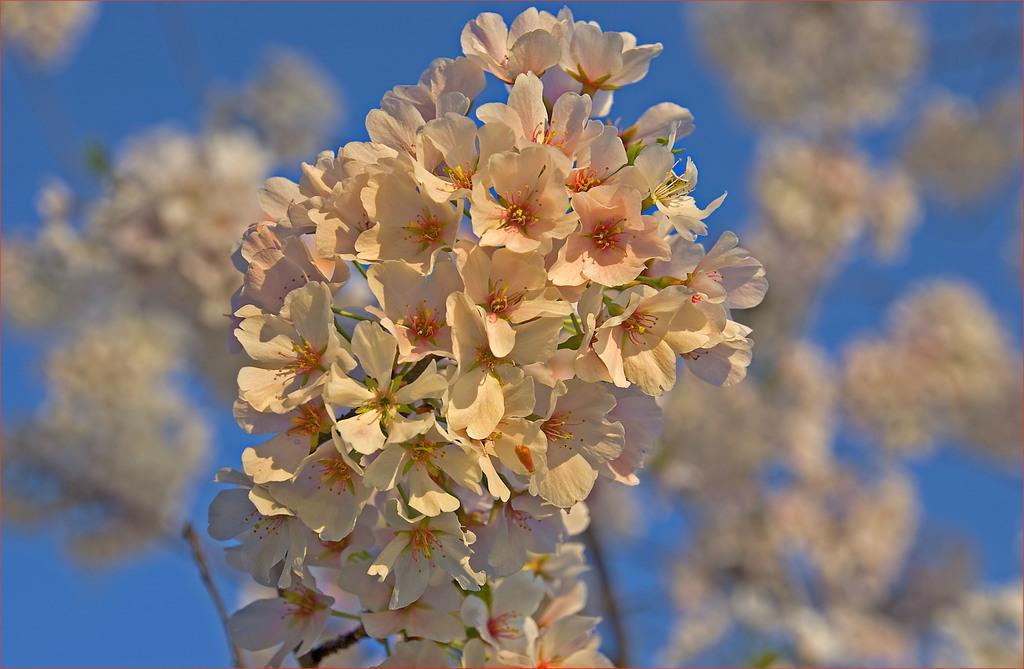Describe this image in one or two sentences. In this image, we can see flowers on the blur background. 